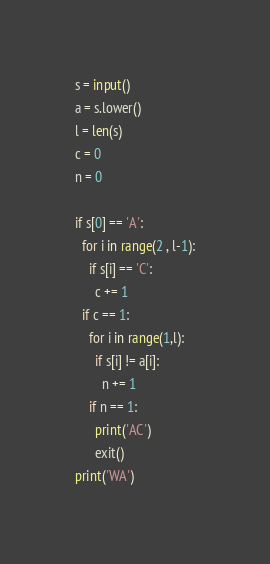<code> <loc_0><loc_0><loc_500><loc_500><_Python_>s = input()
a = s.lower()
l = len(s)
c = 0
n = 0

if s[0] == 'A':
  for i in range(2 , l-1):
    if s[i] == 'C':
      c += 1
  if c == 1:
    for i in range(1,l):
      if s[i] != a[i]:
        n += 1
    if n == 1:
      print('AC')
      exit()
print('WA')</code> 